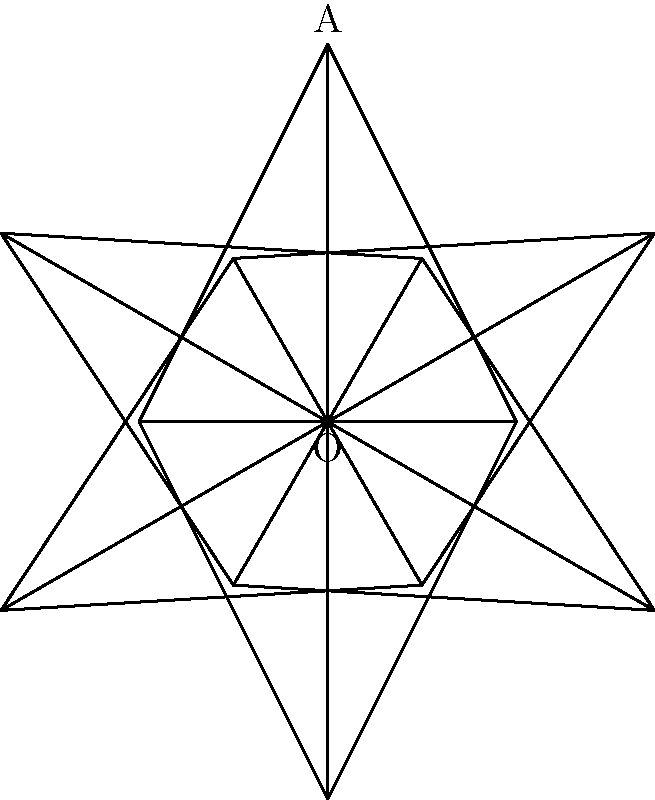A simplified menorah symbol is created by rotating an isosceles triangle around a fixed point O. The original triangle has its apex at point A(0,2) and base corners at B(-1,0) and C(1,0). If this triangle is rotated 60° clockwise five times around point O, how many complete triangles will be formed in total (including the original triangle)? Let's approach this step-by-step:

1) We start with the original triangle OAB.

2) Each rotation is 60° clockwise around point O.

3) We need to consider how many rotations are performed:
   - The question states "rotated 60° clockwise five times"
   - This means we have the original position plus 5 rotations

4) Let's count the triangles:
   - Original position: 1 triangle
   - After 1st rotation: 2 triangles
   - After 2nd rotation: 3 triangles
   - After 3rd rotation: 4 triangles
   - After 4th rotation: 5 triangles
   - After 5th rotation: 6 triangles

5) Therefore, after all rotations, we have 6 complete triangles.

This problem connects to the concept of rotational symmetry, which is significant in Jewish symbolism, particularly in the design of the menorah.
Answer: 6 triangles 